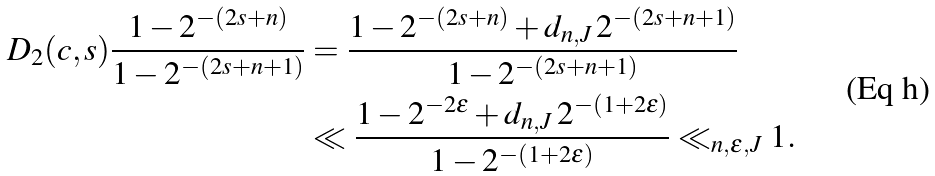<formula> <loc_0><loc_0><loc_500><loc_500>D _ { 2 } ( c , s ) \frac { 1 - 2 ^ { - ( 2 s + n ) } } { 1 - 2 ^ { - ( 2 s + n + 1 ) } } & = \frac { 1 - 2 ^ { - ( 2 s + n ) } + d _ { n , J } \, 2 ^ { - ( 2 s + n + 1 ) } } { 1 - 2 ^ { - ( 2 s + n + 1 ) } } \\ & \ll \frac { 1 - 2 ^ { - 2 \epsilon } + d _ { n , J } \, 2 ^ { - ( 1 + 2 \epsilon ) } } { 1 - 2 ^ { - ( 1 + 2 \epsilon ) } } \ll _ { n , \epsilon , J } 1 .</formula> 